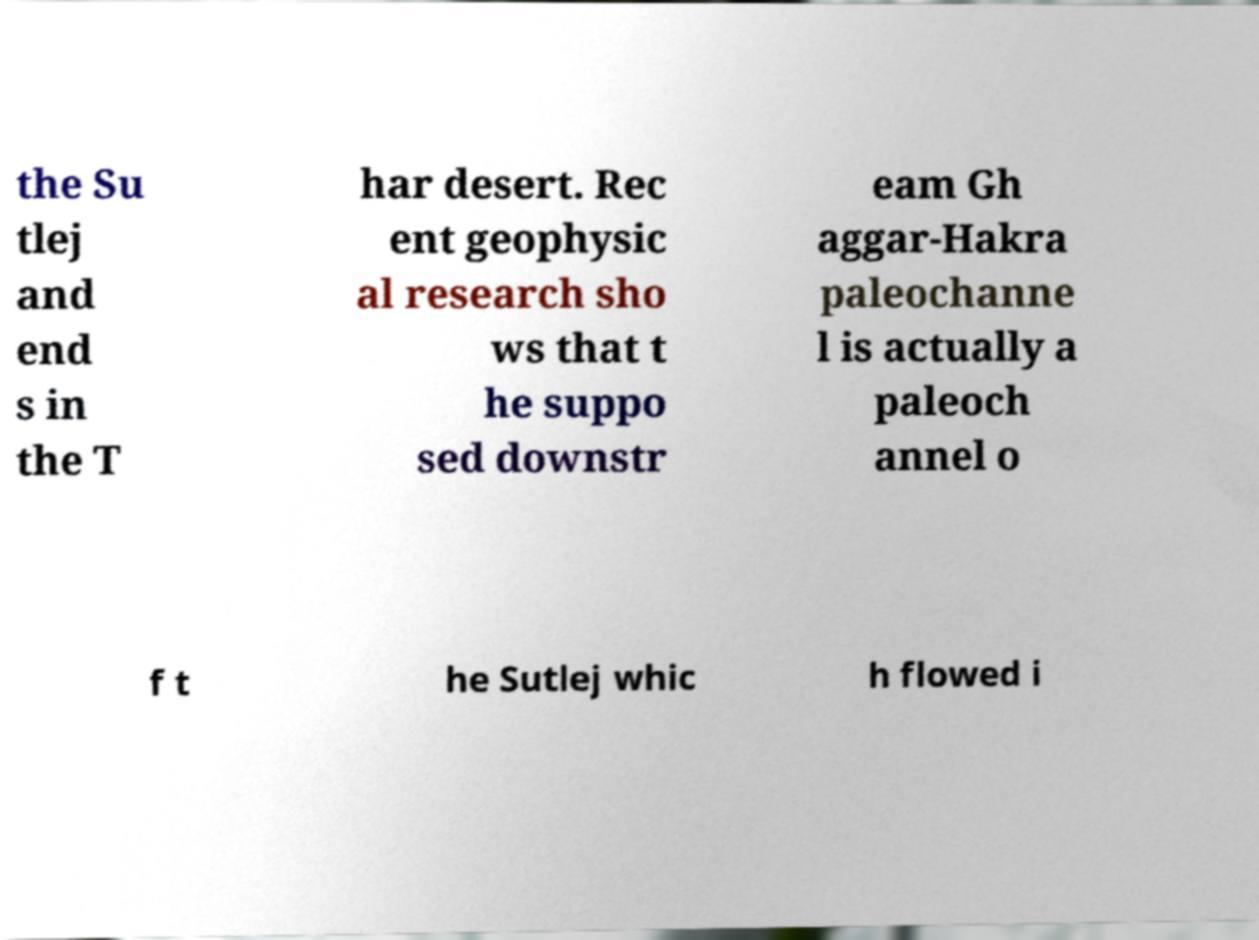Can you read and provide the text displayed in the image?This photo seems to have some interesting text. Can you extract and type it out for me? the Su tlej and end s in the T har desert. Rec ent geophysic al research sho ws that t he suppo sed downstr eam Gh aggar-Hakra paleochanne l is actually a paleoch annel o f t he Sutlej whic h flowed i 